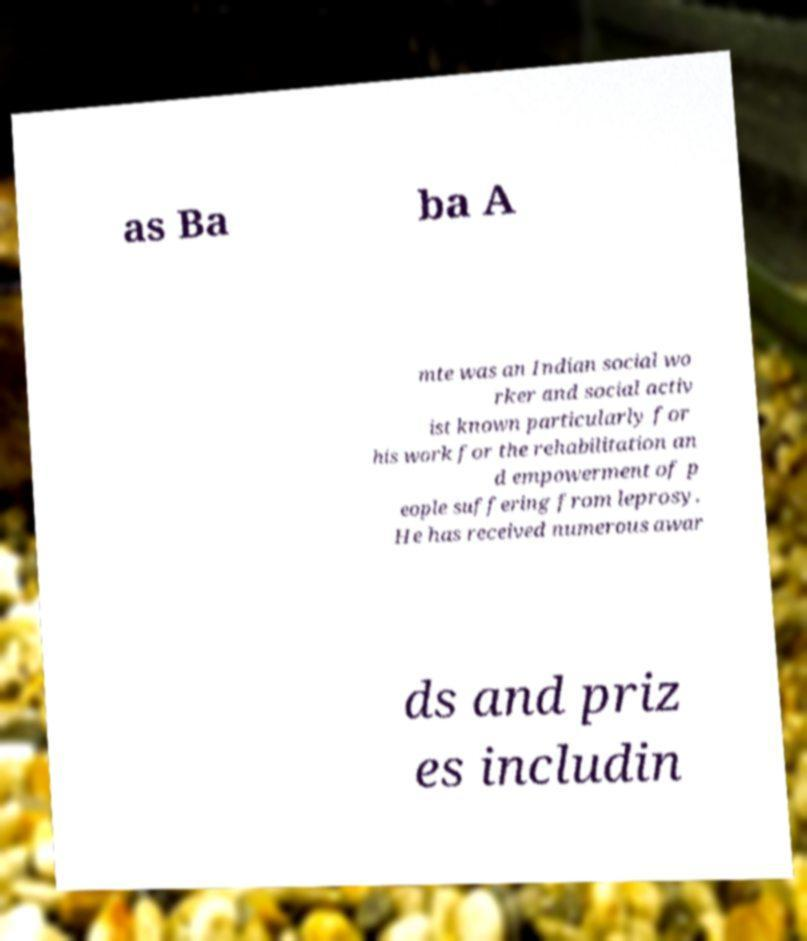Can you accurately transcribe the text from the provided image for me? as Ba ba A mte was an Indian social wo rker and social activ ist known particularly for his work for the rehabilitation an d empowerment of p eople suffering from leprosy. He has received numerous awar ds and priz es includin 